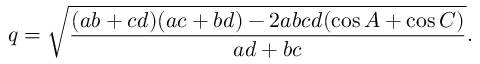Convert formula to latex. <formula><loc_0><loc_0><loc_500><loc_500>q = { \sqrt { \frac { ( a b + c d ) ( a c + b d ) - 2 a b c d ( \cos { A } + \cos { C } ) } { a d + b c } } } .</formula> 